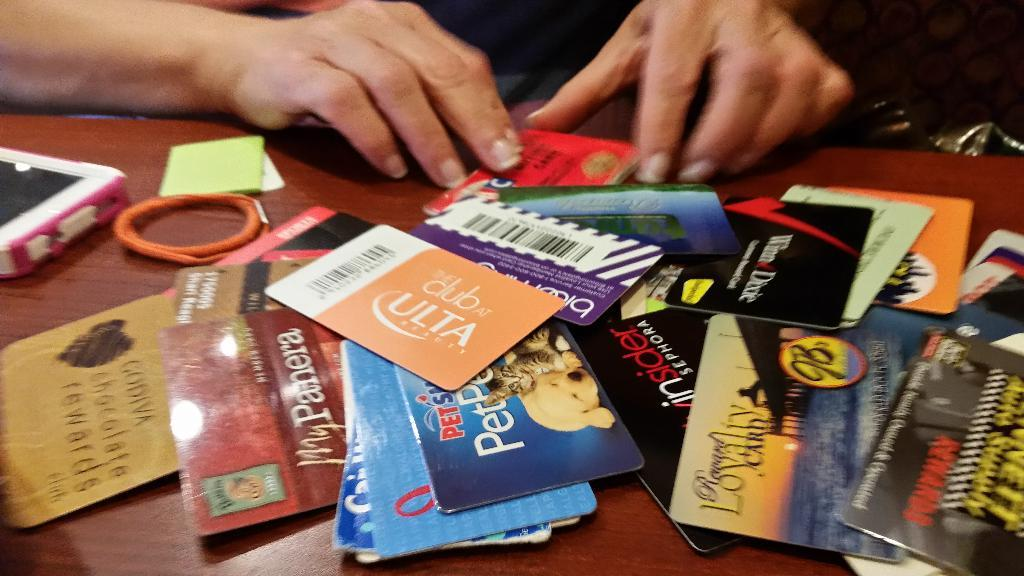<image>
Provide a brief description of the given image. A bar code is seen next to an Ulta logo. 